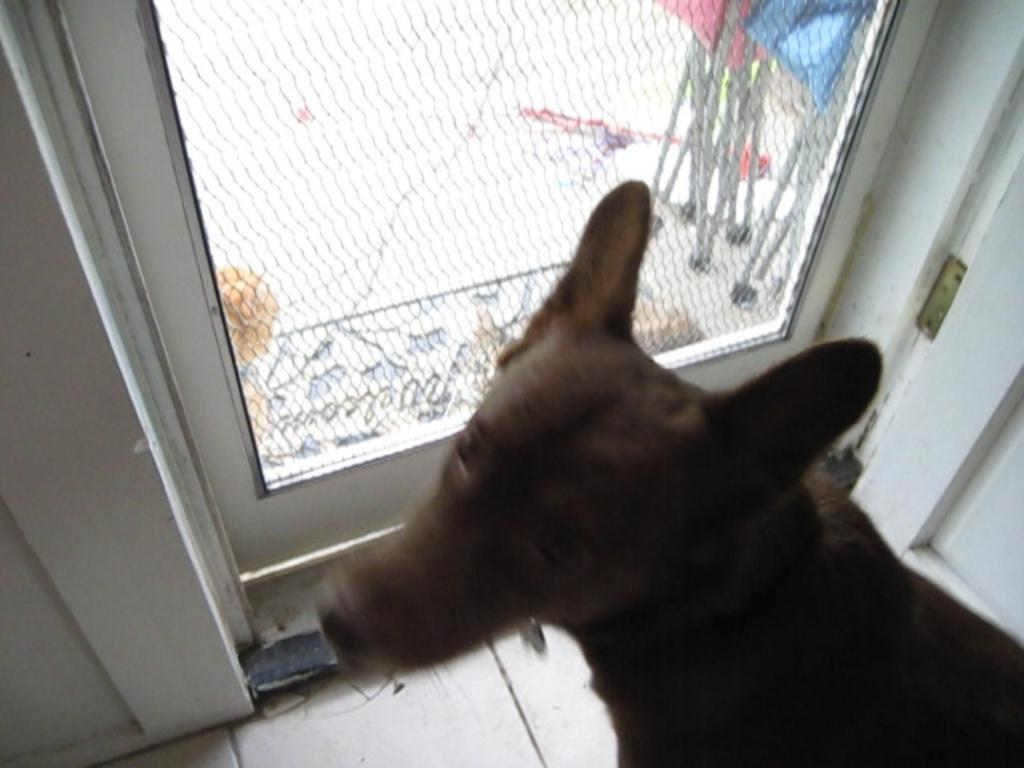What type of creature is in the image? There is an animal in the image. Can you describe the color of the animal? The animal is brown in color. What is the structure visible in the image? There is a glass door in the image. What can be seen through the glass door? Some objects are visible through the glass door. How many oranges are on the tramp in the image? There is no tramp or oranges present in the image. Can you tell me the color of the owl in the image? There is no owl present in the image. 